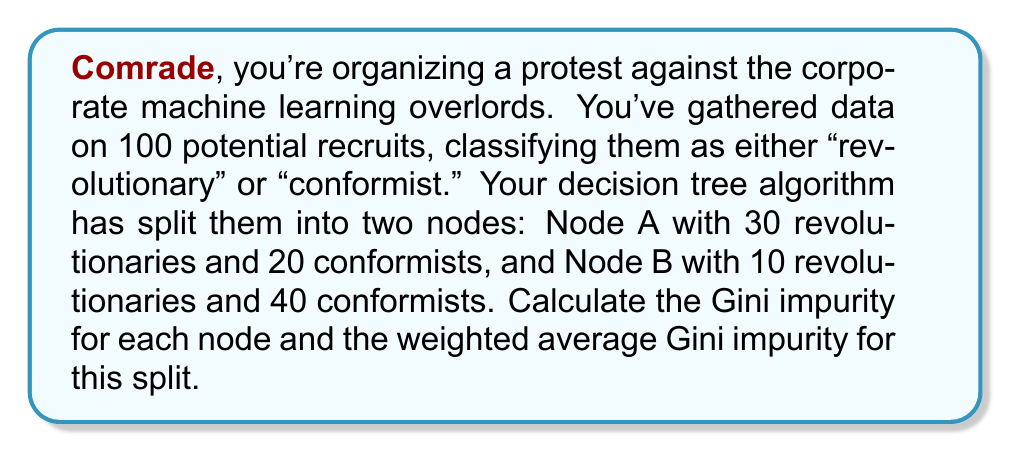Help me with this question. Let's approach this problem step-by-step, comrade:

1) The Gini impurity formula for a binary classification is:

   $$G = 1 - (p_1^2 + p_2^2)$$

   where $p_1$ and $p_2$ are the proportions of each class in the node.

2) For Node A:
   Total samples in Node A = 30 + 20 = 50
   $p_1$ (revolutionary) = 30/50 = 0.6
   $p_2$ (conformist) = 20/50 = 0.4

   $$G_A = 1 - (0.6^2 + 0.4^2) = 1 - (0.36 + 0.16) = 1 - 0.52 = 0.48$$

3) For Node B:
   Total samples in Node B = 10 + 40 = 50
   $p_1$ (revolutionary) = 10/50 = 0.2
   $p_2$ (conformist) = 40/50 = 0.8

   $$G_B = 1 - (0.2^2 + 0.8^2) = 1 - (0.04 + 0.64) = 1 - 0.68 = 0.32$$

4) To calculate the weighted average Gini impurity, we use:

   $$G_{weighted} = \frac{n_A}{N} G_A + \frac{n_B}{N} G_B$$

   where $n_A$ and $n_B$ are the number of samples in each node, and $N$ is the total number of samples.

   $$G_{weighted} = \frac{50}{100} * 0.48 + \frac{50}{100} * 0.32 = 0.24 + 0.16 = 0.40$$

Thus, the weighted average Gini impurity for this split is 0.40.
Answer: Node A Gini impurity: 0.48
Node B Gini impurity: 0.32
Weighted average Gini impurity: 0.40 